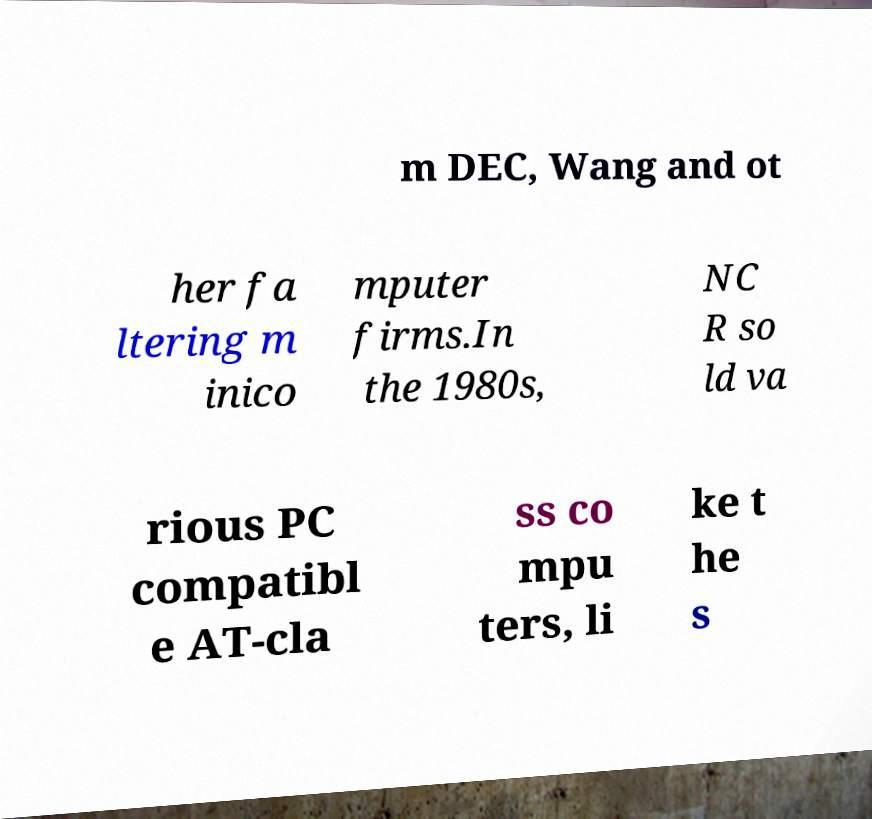Can you accurately transcribe the text from the provided image for me? m DEC, Wang and ot her fa ltering m inico mputer firms.In the 1980s, NC R so ld va rious PC compatibl e AT-cla ss co mpu ters, li ke t he s 